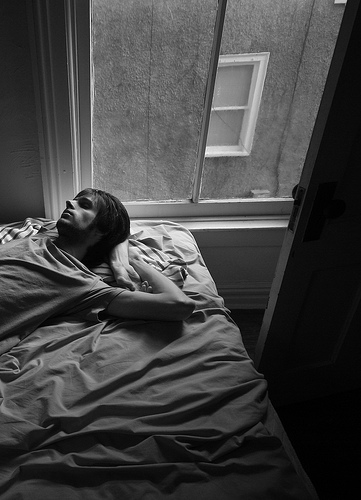What if the window led to another dimension? Describe what that dimension might look like. If the window led to another dimension, it might reveal a fantastical world filled with floating islands, vibrant-colored skies, and an array of strange and magical creatures. The physics and nature of this alternate dimension could be drastically different from our own, with gravity-defying landscapes and surrealistic scenery that defy our comprehension. 